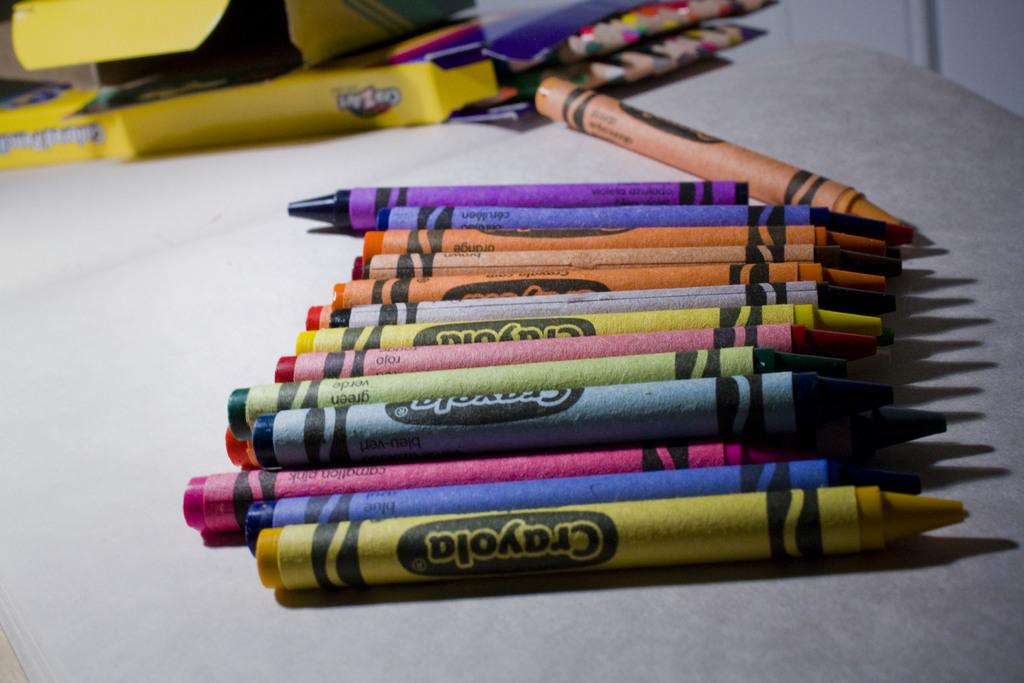Provide a one-sentence caption for the provided image. Several different color Crayola crayons on a table next to the box they came from and also a box of colored pencils. 